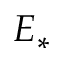<formula> <loc_0><loc_0><loc_500><loc_500>E _ { * }</formula> 